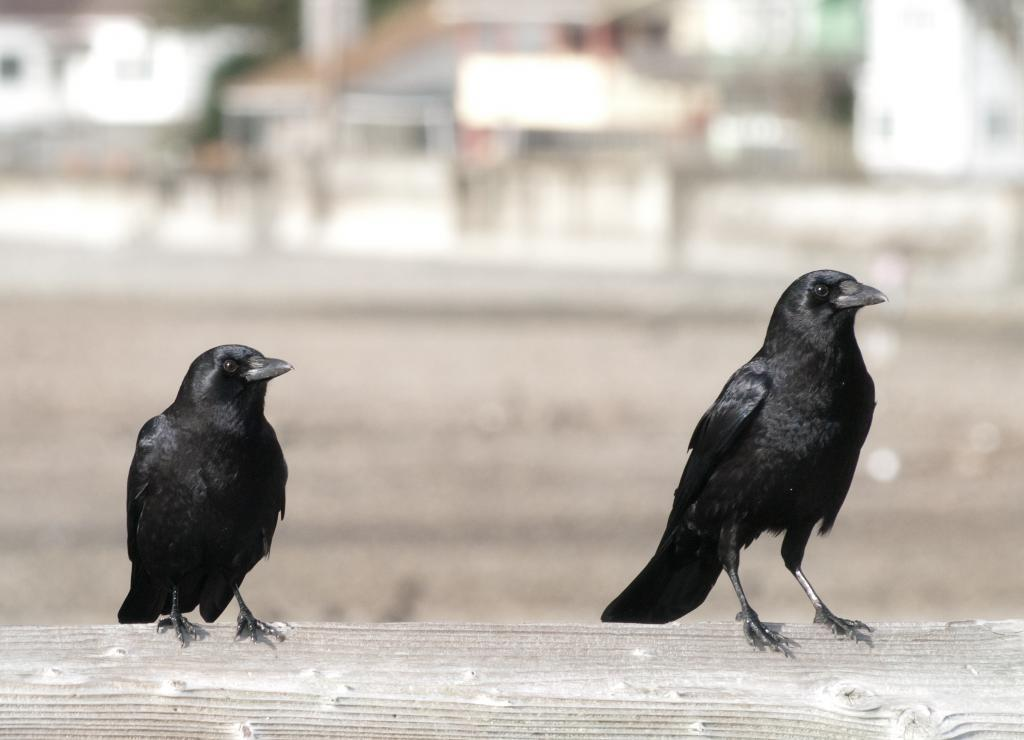What type of birds are in the image? There are crows in the image. Where are the crows located? The crows are on a wooden stick. What is the color of the crows? The crows are black in color. What can be seen in the background of the image? There are buildings in the background of the image. How is the background of the image depicted? The background of the image is blurred. How many bags can be seen hanging from the crows in the image? There are no bags present in the image; it features crows on a wooden stick. What type of zephyr can be seen blowing through the image? There is no zephyr present in the image; it is a still image of crows on a wooden stick with buildings in the background. 